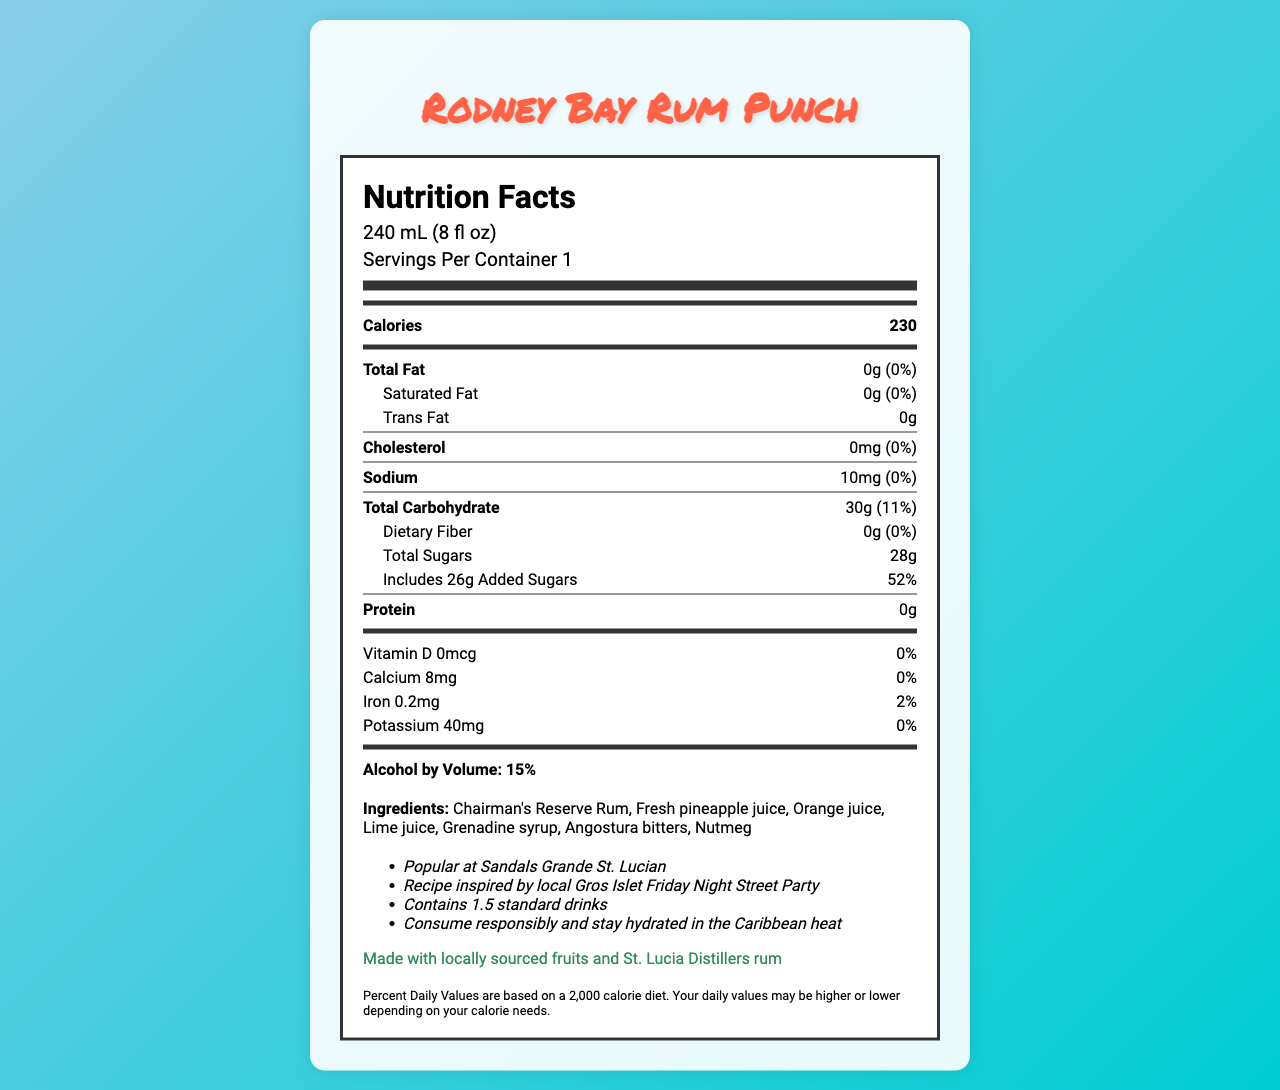What is the serving size of Rodney Bay Rum Punch? The serving size is clearly specified at the top of the document under the nutrition header section.
Answer: 240 mL (8 fl oz) How many calories are in one serving of Rodney Bay Rum Punch? The number of calories per serving is listed in the bold calories section.
Answer: 230 What is the percentage of daily value for total carbohydrates in this drink? The total carbohydrate percentage is provided within the nutrient row for total carbohydrate.
Answer: 11% Does the Rodney Bay Rum Punch contain any fats? The document states that the total fat grams are 0, indicating there are no fats in the product.
Answer: No List three major ingredients in Rodney Bay Rum Punch. The ingredients list includes these three along with other components, prominently mentioned under the ingredients section.
Answer: Chairman's Reserve Rum, Fresh pineapple juice, Orange juice How much sodium is present per serving? This is specified in the sodium section of the nutrition label.
Answer: 10 mg What percentage of daily value of added sugars does one serving of Rodney Bay Rum Punch have? The percentage of added sugars is given next to the added sugars entry under total carbohydrate.
Answer: 52% Which vitamin is completely absent in Rodney Bay Rum Punch? The document specifies 0 mcg and 0% for Vitamin D.
Answer: Vitamin D How much protein does this drink provide per serving? The nutrient row for protein clearly states 0 grams.
Answer: 0 grams Are there any allergens listed for the Rodney Bay Rum Punch? The document clearly mentions that there are no allergens.
Answer: None What is the alcohol by volume (ABV) percentage for Rodney Bay Rum Punch? The ABV is explicitly stated under the nutrition label.
Answer: 15% Where is this rum punch most popular? A. Sandals Grande Antigua B. Sandals Grande St. Lucian C. Sandals Grande Barbados D. Sandals Regency La Toc The additional information section states that it's popular at Sandals Grande St. Lucian.
Answer: B. Sandals Grande St. Lucian Which local event inspired the recipe? A. Gros Islet Friday Night Street Party B. Rodney Bay Jazz Festival C. Soufriere Creole Day D. Micoud Cultural Fair The additional info mentions that the recipe was inspired by the local Gros Islet Friday Night Street Party.
Answer: A. Gros Islet Friday Night Street Party Does the drink contain any cholesterol? The document lists 0 mg and 0% for cholesterol.
Answer: No Summarize the information presented in the nutrition facts label. Rodney Bay Rum Punch is a popular Caribbean drink served at Saint Lucia resorts. It has a serving size of 240 mL, 230 calories per serving, with no fats, proteins, or dietary fiber. It contains 30 grams of carbohydrates, including 28 grams of sugars and 26 grams of added sugars, resulting in 52% of the daily value for added sugars. The drink contains 10 mg of sodium and minimal amounts of iron and potassium. The ingredients include local fruits and St. Lucia Distillers' rum with no allergens. It has an alcohol content of 15% ABV and is known for its popularity at the Sandals Grande St. Lucian Resort, with a recipe inspired by the Gros Islet Street Party. What percentage of daily value of calcium does the Rodney Bay Rum Punch provide? The document states that the daily value percentage for calcium is 0.
Answer: 0% How many standard drinks does this product contain? This information is noted in the additional info section, stating it contains 1.5 standard drinks.
Answer: 1.5 standard drinks What is the source of the fruits used in Rodney Bay Rum Punch? The sustainability note mentions that the fruits are locally sourced in Saint Lucia.
Answer: Locally sourced in Saint Lucia Which company prepared the drink? The manufacturer info states it is prepared fresh at resort bars across Saint Lucia.
Answer: Prepared fresh at resort bars across Saint Lucia How much vitamin C is in the Rodney Bay Rum Punch? The document does not provide any details about the vitamin C content.
Answer: Not enough information 